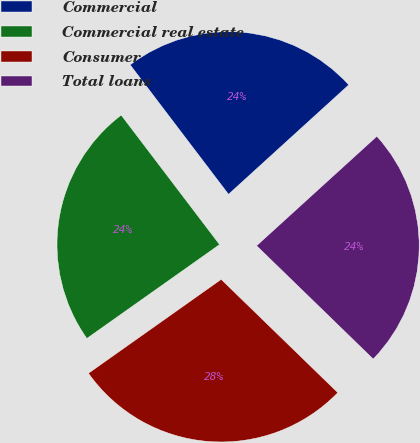Convert chart to OTSL. <chart><loc_0><loc_0><loc_500><loc_500><pie_chart><fcel>Commercial<fcel>Commercial real estate<fcel>Consumer<fcel>Total loans<nl><fcel>23.59%<fcel>24.46%<fcel>27.93%<fcel>24.02%<nl></chart> 